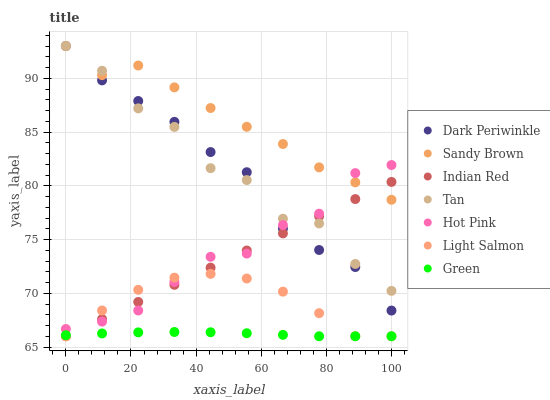Does Green have the minimum area under the curve?
Answer yes or no. Yes. Does Sandy Brown have the maximum area under the curve?
Answer yes or no. Yes. Does Hot Pink have the minimum area under the curve?
Answer yes or no. No. Does Hot Pink have the maximum area under the curve?
Answer yes or no. No. Is Indian Red the smoothest?
Answer yes or no. Yes. Is Tan the roughest?
Answer yes or no. Yes. Is Hot Pink the smoothest?
Answer yes or no. No. Is Hot Pink the roughest?
Answer yes or no. No. Does Light Salmon have the lowest value?
Answer yes or no. Yes. Does Hot Pink have the lowest value?
Answer yes or no. No. Does Dark Periwinkle have the highest value?
Answer yes or no. Yes. Does Hot Pink have the highest value?
Answer yes or no. No. Is Green less than Tan?
Answer yes or no. Yes. Is Hot Pink greater than Green?
Answer yes or no. Yes. Does Hot Pink intersect Indian Red?
Answer yes or no. Yes. Is Hot Pink less than Indian Red?
Answer yes or no. No. Is Hot Pink greater than Indian Red?
Answer yes or no. No. Does Green intersect Tan?
Answer yes or no. No. 